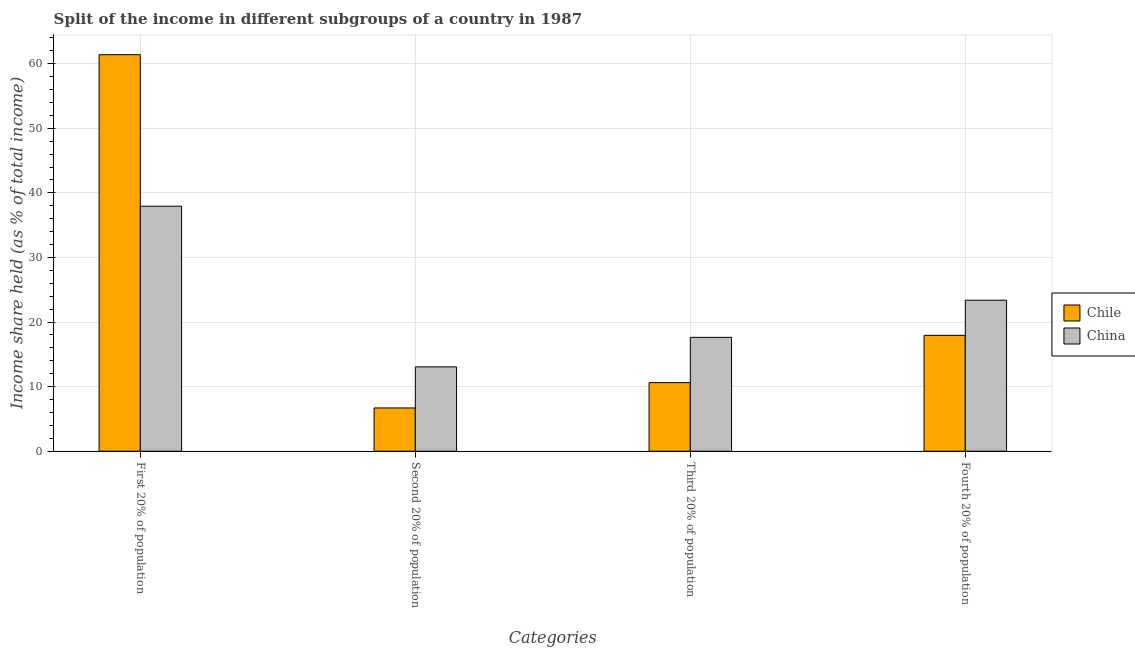How many groups of bars are there?
Provide a short and direct response. 4. How many bars are there on the 1st tick from the left?
Provide a succinct answer. 2. What is the label of the 4th group of bars from the left?
Make the answer very short. Fourth 20% of population. What is the share of the income held by first 20% of the population in Chile?
Keep it short and to the point. 61.4. Across all countries, what is the maximum share of the income held by fourth 20% of the population?
Offer a terse response. 23.38. In which country was the share of the income held by second 20% of the population maximum?
Ensure brevity in your answer.  China. What is the total share of the income held by first 20% of the population in the graph?
Make the answer very short. 99.34. What is the difference between the share of the income held by fourth 20% of the population in Chile and that in China?
Ensure brevity in your answer.  -5.44. What is the difference between the share of the income held by second 20% of the population in China and the share of the income held by fourth 20% of the population in Chile?
Ensure brevity in your answer.  -4.88. What is the average share of the income held by first 20% of the population per country?
Keep it short and to the point. 49.67. What is the difference between the share of the income held by fourth 20% of the population and share of the income held by second 20% of the population in China?
Offer a terse response. 10.32. In how many countries, is the share of the income held by third 20% of the population greater than 40 %?
Ensure brevity in your answer.  0. What is the ratio of the share of the income held by second 20% of the population in Chile to that in China?
Offer a very short reply. 0.51. Is the share of the income held by third 20% of the population in Chile less than that in China?
Offer a terse response. Yes. What is the difference between the highest and the second highest share of the income held by first 20% of the population?
Give a very brief answer. 23.46. What is the difference between the highest and the lowest share of the income held by second 20% of the population?
Your response must be concise. 6.36. What does the 2nd bar from the left in Fourth 20% of population represents?
Offer a very short reply. China. What does the 1st bar from the right in Third 20% of population represents?
Your answer should be very brief. China. How many bars are there?
Your answer should be compact. 8. How many countries are there in the graph?
Your answer should be compact. 2. Does the graph contain any zero values?
Keep it short and to the point. No. Does the graph contain grids?
Your response must be concise. Yes. How are the legend labels stacked?
Provide a succinct answer. Vertical. What is the title of the graph?
Your answer should be very brief. Split of the income in different subgroups of a country in 1987. What is the label or title of the X-axis?
Offer a very short reply. Categories. What is the label or title of the Y-axis?
Your answer should be very brief. Income share held (as % of total income). What is the Income share held (as % of total income) in Chile in First 20% of population?
Provide a short and direct response. 61.4. What is the Income share held (as % of total income) of China in First 20% of population?
Keep it short and to the point. 37.94. What is the Income share held (as % of total income) of China in Second 20% of population?
Offer a terse response. 13.06. What is the Income share held (as % of total income) of Chile in Third 20% of population?
Your answer should be compact. 10.62. What is the Income share held (as % of total income) in China in Third 20% of population?
Give a very brief answer. 17.63. What is the Income share held (as % of total income) in Chile in Fourth 20% of population?
Offer a terse response. 17.94. What is the Income share held (as % of total income) of China in Fourth 20% of population?
Ensure brevity in your answer.  23.38. Across all Categories, what is the maximum Income share held (as % of total income) of Chile?
Provide a short and direct response. 61.4. Across all Categories, what is the maximum Income share held (as % of total income) in China?
Give a very brief answer. 37.94. Across all Categories, what is the minimum Income share held (as % of total income) in Chile?
Provide a short and direct response. 6.7. Across all Categories, what is the minimum Income share held (as % of total income) in China?
Offer a terse response. 13.06. What is the total Income share held (as % of total income) of Chile in the graph?
Make the answer very short. 96.66. What is the total Income share held (as % of total income) in China in the graph?
Your response must be concise. 92.01. What is the difference between the Income share held (as % of total income) in Chile in First 20% of population and that in Second 20% of population?
Your answer should be compact. 54.7. What is the difference between the Income share held (as % of total income) of China in First 20% of population and that in Second 20% of population?
Give a very brief answer. 24.88. What is the difference between the Income share held (as % of total income) in Chile in First 20% of population and that in Third 20% of population?
Offer a very short reply. 50.78. What is the difference between the Income share held (as % of total income) in China in First 20% of population and that in Third 20% of population?
Give a very brief answer. 20.31. What is the difference between the Income share held (as % of total income) of Chile in First 20% of population and that in Fourth 20% of population?
Offer a very short reply. 43.46. What is the difference between the Income share held (as % of total income) in China in First 20% of population and that in Fourth 20% of population?
Provide a succinct answer. 14.56. What is the difference between the Income share held (as % of total income) in Chile in Second 20% of population and that in Third 20% of population?
Offer a terse response. -3.92. What is the difference between the Income share held (as % of total income) of China in Second 20% of population and that in Third 20% of population?
Your answer should be very brief. -4.57. What is the difference between the Income share held (as % of total income) of Chile in Second 20% of population and that in Fourth 20% of population?
Keep it short and to the point. -11.24. What is the difference between the Income share held (as % of total income) in China in Second 20% of population and that in Fourth 20% of population?
Your answer should be compact. -10.32. What is the difference between the Income share held (as % of total income) in Chile in Third 20% of population and that in Fourth 20% of population?
Offer a terse response. -7.32. What is the difference between the Income share held (as % of total income) in China in Third 20% of population and that in Fourth 20% of population?
Offer a terse response. -5.75. What is the difference between the Income share held (as % of total income) in Chile in First 20% of population and the Income share held (as % of total income) in China in Second 20% of population?
Your answer should be compact. 48.34. What is the difference between the Income share held (as % of total income) of Chile in First 20% of population and the Income share held (as % of total income) of China in Third 20% of population?
Your answer should be very brief. 43.77. What is the difference between the Income share held (as % of total income) in Chile in First 20% of population and the Income share held (as % of total income) in China in Fourth 20% of population?
Your response must be concise. 38.02. What is the difference between the Income share held (as % of total income) of Chile in Second 20% of population and the Income share held (as % of total income) of China in Third 20% of population?
Give a very brief answer. -10.93. What is the difference between the Income share held (as % of total income) of Chile in Second 20% of population and the Income share held (as % of total income) of China in Fourth 20% of population?
Your answer should be very brief. -16.68. What is the difference between the Income share held (as % of total income) of Chile in Third 20% of population and the Income share held (as % of total income) of China in Fourth 20% of population?
Give a very brief answer. -12.76. What is the average Income share held (as % of total income) in Chile per Categories?
Keep it short and to the point. 24.16. What is the average Income share held (as % of total income) of China per Categories?
Ensure brevity in your answer.  23. What is the difference between the Income share held (as % of total income) of Chile and Income share held (as % of total income) of China in First 20% of population?
Ensure brevity in your answer.  23.46. What is the difference between the Income share held (as % of total income) in Chile and Income share held (as % of total income) in China in Second 20% of population?
Keep it short and to the point. -6.36. What is the difference between the Income share held (as % of total income) of Chile and Income share held (as % of total income) of China in Third 20% of population?
Your response must be concise. -7.01. What is the difference between the Income share held (as % of total income) of Chile and Income share held (as % of total income) of China in Fourth 20% of population?
Your answer should be compact. -5.44. What is the ratio of the Income share held (as % of total income) in Chile in First 20% of population to that in Second 20% of population?
Make the answer very short. 9.16. What is the ratio of the Income share held (as % of total income) of China in First 20% of population to that in Second 20% of population?
Give a very brief answer. 2.91. What is the ratio of the Income share held (as % of total income) in Chile in First 20% of population to that in Third 20% of population?
Your answer should be very brief. 5.78. What is the ratio of the Income share held (as % of total income) in China in First 20% of population to that in Third 20% of population?
Offer a very short reply. 2.15. What is the ratio of the Income share held (as % of total income) in Chile in First 20% of population to that in Fourth 20% of population?
Ensure brevity in your answer.  3.42. What is the ratio of the Income share held (as % of total income) of China in First 20% of population to that in Fourth 20% of population?
Your answer should be compact. 1.62. What is the ratio of the Income share held (as % of total income) in Chile in Second 20% of population to that in Third 20% of population?
Your response must be concise. 0.63. What is the ratio of the Income share held (as % of total income) in China in Second 20% of population to that in Third 20% of population?
Your response must be concise. 0.74. What is the ratio of the Income share held (as % of total income) of Chile in Second 20% of population to that in Fourth 20% of population?
Keep it short and to the point. 0.37. What is the ratio of the Income share held (as % of total income) of China in Second 20% of population to that in Fourth 20% of population?
Provide a succinct answer. 0.56. What is the ratio of the Income share held (as % of total income) of Chile in Third 20% of population to that in Fourth 20% of population?
Offer a very short reply. 0.59. What is the ratio of the Income share held (as % of total income) in China in Third 20% of population to that in Fourth 20% of population?
Provide a short and direct response. 0.75. What is the difference between the highest and the second highest Income share held (as % of total income) in Chile?
Give a very brief answer. 43.46. What is the difference between the highest and the second highest Income share held (as % of total income) in China?
Your response must be concise. 14.56. What is the difference between the highest and the lowest Income share held (as % of total income) of Chile?
Give a very brief answer. 54.7. What is the difference between the highest and the lowest Income share held (as % of total income) of China?
Offer a terse response. 24.88. 